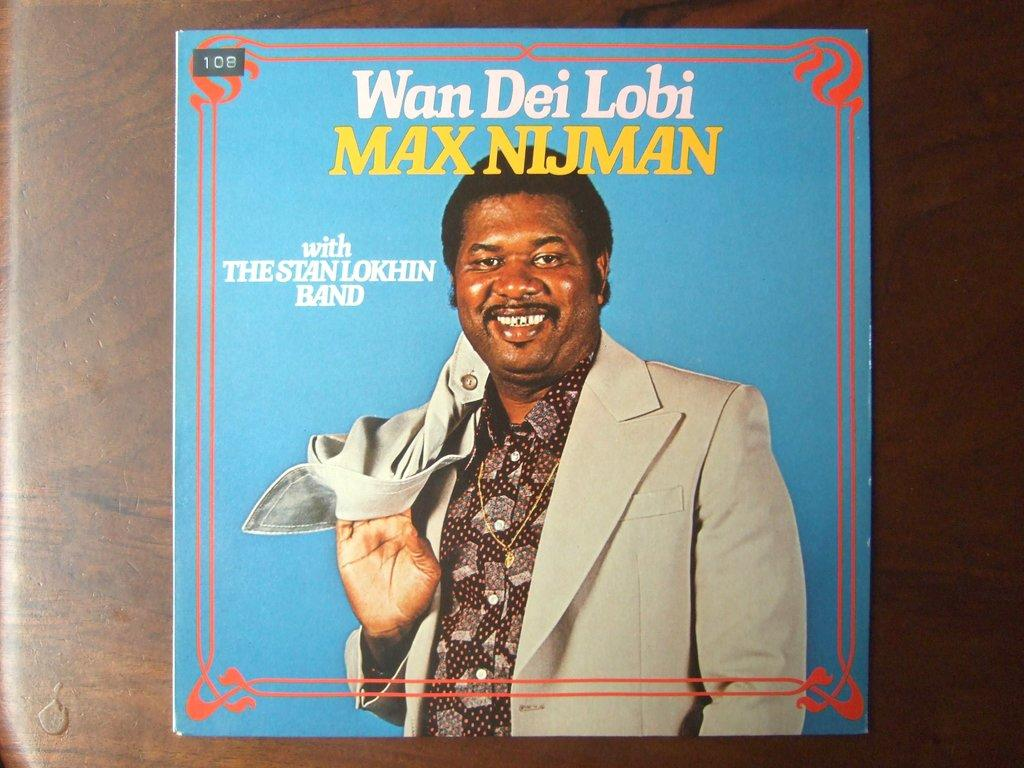What is the main subject of the image? The main subject of the image is a person's photograph. Can you describe any design elements in the photograph? Yes, the photograph has some design. What is written or printed near the photograph? There is text associated with the photograph. Where is the photograph and text located in the image? The photograph and text are stuck to the wall. What type of arithmetic problem is being solved in the image? There is no arithmetic problem present in the image; it features a person's photograph with design and text. How is the bait being used in the image? There is no bait present in the image; it only contains a person's photograph, design, text, and their location on the wall. 